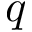<formula> <loc_0><loc_0><loc_500><loc_500>q</formula> 